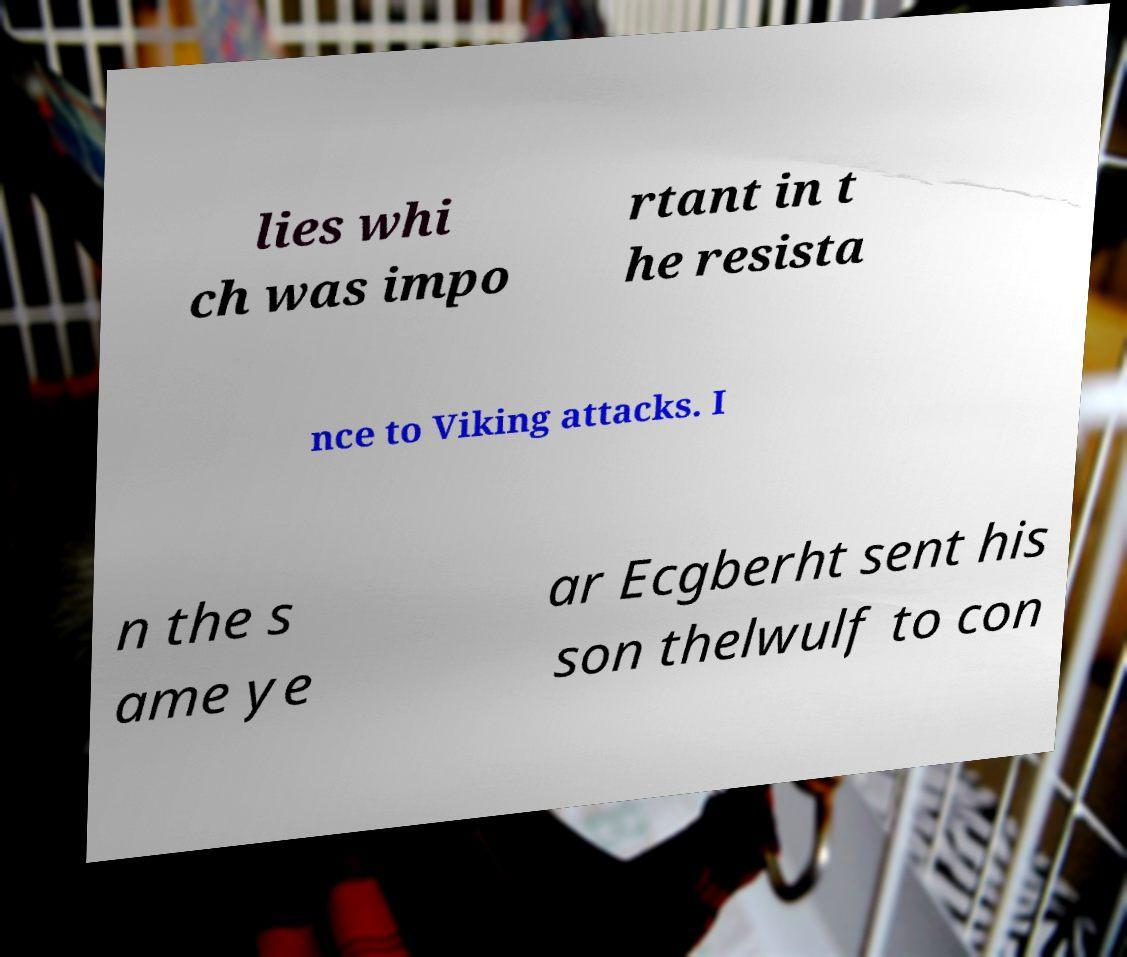Can you read and provide the text displayed in the image?This photo seems to have some interesting text. Can you extract and type it out for me? lies whi ch was impo rtant in t he resista nce to Viking attacks. I n the s ame ye ar Ecgberht sent his son thelwulf to con 